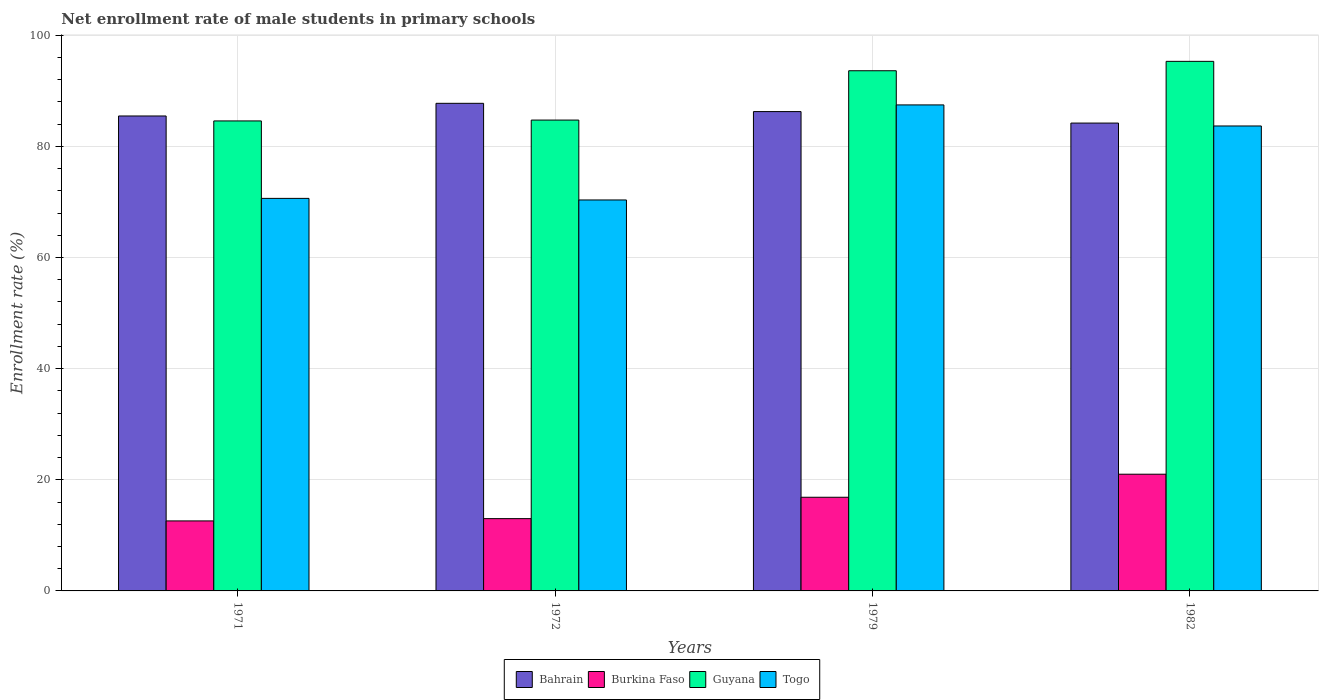How many groups of bars are there?
Give a very brief answer. 4. Are the number of bars on each tick of the X-axis equal?
Make the answer very short. Yes. How many bars are there on the 3rd tick from the right?
Offer a terse response. 4. What is the label of the 3rd group of bars from the left?
Offer a very short reply. 1979. In how many cases, is the number of bars for a given year not equal to the number of legend labels?
Your response must be concise. 0. What is the net enrollment rate of male students in primary schools in Togo in 1979?
Offer a very short reply. 87.47. Across all years, what is the maximum net enrollment rate of male students in primary schools in Burkina Faso?
Make the answer very short. 21.01. Across all years, what is the minimum net enrollment rate of male students in primary schools in Guyana?
Give a very brief answer. 84.59. In which year was the net enrollment rate of male students in primary schools in Burkina Faso minimum?
Your answer should be compact. 1971. What is the total net enrollment rate of male students in primary schools in Burkina Faso in the graph?
Your answer should be compact. 63.47. What is the difference between the net enrollment rate of male students in primary schools in Bahrain in 1979 and that in 1982?
Ensure brevity in your answer.  2.07. What is the difference between the net enrollment rate of male students in primary schools in Togo in 1971 and the net enrollment rate of male students in primary schools in Guyana in 1979?
Your answer should be very brief. -22.97. What is the average net enrollment rate of male students in primary schools in Bahrain per year?
Provide a short and direct response. 85.92. In the year 1972, what is the difference between the net enrollment rate of male students in primary schools in Guyana and net enrollment rate of male students in primary schools in Togo?
Your response must be concise. 14.38. In how many years, is the net enrollment rate of male students in primary schools in Togo greater than 96 %?
Give a very brief answer. 0. What is the ratio of the net enrollment rate of male students in primary schools in Burkina Faso in 1971 to that in 1982?
Provide a short and direct response. 0.6. Is the net enrollment rate of male students in primary schools in Burkina Faso in 1971 less than that in 1982?
Give a very brief answer. Yes. Is the difference between the net enrollment rate of male students in primary schools in Guyana in 1979 and 1982 greater than the difference between the net enrollment rate of male students in primary schools in Togo in 1979 and 1982?
Offer a terse response. No. What is the difference between the highest and the second highest net enrollment rate of male students in primary schools in Bahrain?
Provide a short and direct response. 1.49. What is the difference between the highest and the lowest net enrollment rate of male students in primary schools in Bahrain?
Provide a succinct answer. 3.55. Is it the case that in every year, the sum of the net enrollment rate of male students in primary schools in Togo and net enrollment rate of male students in primary schools in Guyana is greater than the sum of net enrollment rate of male students in primary schools in Burkina Faso and net enrollment rate of male students in primary schools in Bahrain?
Ensure brevity in your answer.  No. What does the 3rd bar from the left in 1971 represents?
Provide a short and direct response. Guyana. What does the 3rd bar from the right in 1972 represents?
Keep it short and to the point. Burkina Faso. Are all the bars in the graph horizontal?
Give a very brief answer. No. How many years are there in the graph?
Ensure brevity in your answer.  4. What is the difference between two consecutive major ticks on the Y-axis?
Keep it short and to the point. 20. Does the graph contain any zero values?
Provide a short and direct response. No. How many legend labels are there?
Ensure brevity in your answer.  4. How are the legend labels stacked?
Provide a short and direct response. Horizontal. What is the title of the graph?
Offer a terse response. Net enrollment rate of male students in primary schools. What is the label or title of the X-axis?
Your answer should be very brief. Years. What is the label or title of the Y-axis?
Give a very brief answer. Enrollment rate (%). What is the Enrollment rate (%) of Bahrain in 1971?
Offer a terse response. 85.48. What is the Enrollment rate (%) in Burkina Faso in 1971?
Make the answer very short. 12.6. What is the Enrollment rate (%) in Guyana in 1971?
Ensure brevity in your answer.  84.59. What is the Enrollment rate (%) of Togo in 1971?
Give a very brief answer. 70.65. What is the Enrollment rate (%) in Bahrain in 1972?
Your response must be concise. 87.75. What is the Enrollment rate (%) of Burkina Faso in 1972?
Your response must be concise. 13.01. What is the Enrollment rate (%) in Guyana in 1972?
Your answer should be very brief. 84.74. What is the Enrollment rate (%) of Togo in 1972?
Make the answer very short. 70.36. What is the Enrollment rate (%) in Bahrain in 1979?
Give a very brief answer. 86.27. What is the Enrollment rate (%) of Burkina Faso in 1979?
Keep it short and to the point. 16.86. What is the Enrollment rate (%) of Guyana in 1979?
Your response must be concise. 93.62. What is the Enrollment rate (%) of Togo in 1979?
Your answer should be compact. 87.47. What is the Enrollment rate (%) in Bahrain in 1982?
Offer a terse response. 84.2. What is the Enrollment rate (%) in Burkina Faso in 1982?
Your answer should be very brief. 21.01. What is the Enrollment rate (%) of Guyana in 1982?
Provide a succinct answer. 95.31. What is the Enrollment rate (%) of Togo in 1982?
Make the answer very short. 83.68. Across all years, what is the maximum Enrollment rate (%) in Bahrain?
Ensure brevity in your answer.  87.75. Across all years, what is the maximum Enrollment rate (%) in Burkina Faso?
Make the answer very short. 21.01. Across all years, what is the maximum Enrollment rate (%) of Guyana?
Ensure brevity in your answer.  95.31. Across all years, what is the maximum Enrollment rate (%) of Togo?
Make the answer very short. 87.47. Across all years, what is the minimum Enrollment rate (%) in Bahrain?
Make the answer very short. 84.2. Across all years, what is the minimum Enrollment rate (%) in Burkina Faso?
Your answer should be very brief. 12.6. Across all years, what is the minimum Enrollment rate (%) of Guyana?
Provide a short and direct response. 84.59. Across all years, what is the minimum Enrollment rate (%) of Togo?
Your answer should be very brief. 70.36. What is the total Enrollment rate (%) of Bahrain in the graph?
Offer a very short reply. 343.7. What is the total Enrollment rate (%) in Burkina Faso in the graph?
Provide a short and direct response. 63.47. What is the total Enrollment rate (%) in Guyana in the graph?
Ensure brevity in your answer.  358.25. What is the total Enrollment rate (%) in Togo in the graph?
Your response must be concise. 312.16. What is the difference between the Enrollment rate (%) of Bahrain in 1971 and that in 1972?
Your answer should be very brief. -2.28. What is the difference between the Enrollment rate (%) in Burkina Faso in 1971 and that in 1972?
Provide a succinct answer. -0.41. What is the difference between the Enrollment rate (%) of Guyana in 1971 and that in 1972?
Your response must be concise. -0.15. What is the difference between the Enrollment rate (%) of Togo in 1971 and that in 1972?
Ensure brevity in your answer.  0.28. What is the difference between the Enrollment rate (%) in Bahrain in 1971 and that in 1979?
Provide a succinct answer. -0.79. What is the difference between the Enrollment rate (%) of Burkina Faso in 1971 and that in 1979?
Your answer should be compact. -4.26. What is the difference between the Enrollment rate (%) of Guyana in 1971 and that in 1979?
Ensure brevity in your answer.  -9.03. What is the difference between the Enrollment rate (%) in Togo in 1971 and that in 1979?
Your answer should be compact. -16.82. What is the difference between the Enrollment rate (%) in Bahrain in 1971 and that in 1982?
Make the answer very short. 1.28. What is the difference between the Enrollment rate (%) of Burkina Faso in 1971 and that in 1982?
Your answer should be very brief. -8.4. What is the difference between the Enrollment rate (%) in Guyana in 1971 and that in 1982?
Offer a very short reply. -10.72. What is the difference between the Enrollment rate (%) of Togo in 1971 and that in 1982?
Your response must be concise. -13.03. What is the difference between the Enrollment rate (%) in Bahrain in 1972 and that in 1979?
Your answer should be very brief. 1.49. What is the difference between the Enrollment rate (%) of Burkina Faso in 1972 and that in 1979?
Make the answer very short. -3.84. What is the difference between the Enrollment rate (%) in Guyana in 1972 and that in 1979?
Keep it short and to the point. -8.88. What is the difference between the Enrollment rate (%) of Togo in 1972 and that in 1979?
Make the answer very short. -17.11. What is the difference between the Enrollment rate (%) in Bahrain in 1972 and that in 1982?
Provide a short and direct response. 3.55. What is the difference between the Enrollment rate (%) of Burkina Faso in 1972 and that in 1982?
Offer a terse response. -7.99. What is the difference between the Enrollment rate (%) in Guyana in 1972 and that in 1982?
Offer a very short reply. -10.57. What is the difference between the Enrollment rate (%) in Togo in 1972 and that in 1982?
Provide a short and direct response. -13.32. What is the difference between the Enrollment rate (%) of Bahrain in 1979 and that in 1982?
Offer a very short reply. 2.07. What is the difference between the Enrollment rate (%) in Burkina Faso in 1979 and that in 1982?
Your response must be concise. -4.15. What is the difference between the Enrollment rate (%) in Guyana in 1979 and that in 1982?
Provide a succinct answer. -1.69. What is the difference between the Enrollment rate (%) of Togo in 1979 and that in 1982?
Provide a short and direct response. 3.79. What is the difference between the Enrollment rate (%) in Bahrain in 1971 and the Enrollment rate (%) in Burkina Faso in 1972?
Ensure brevity in your answer.  72.47. What is the difference between the Enrollment rate (%) in Bahrain in 1971 and the Enrollment rate (%) in Guyana in 1972?
Provide a short and direct response. 0.74. What is the difference between the Enrollment rate (%) of Bahrain in 1971 and the Enrollment rate (%) of Togo in 1972?
Your answer should be compact. 15.11. What is the difference between the Enrollment rate (%) of Burkina Faso in 1971 and the Enrollment rate (%) of Guyana in 1972?
Make the answer very short. -72.14. What is the difference between the Enrollment rate (%) of Burkina Faso in 1971 and the Enrollment rate (%) of Togo in 1972?
Your answer should be very brief. -57.76. What is the difference between the Enrollment rate (%) of Guyana in 1971 and the Enrollment rate (%) of Togo in 1972?
Your answer should be very brief. 14.22. What is the difference between the Enrollment rate (%) in Bahrain in 1971 and the Enrollment rate (%) in Burkina Faso in 1979?
Ensure brevity in your answer.  68.62. What is the difference between the Enrollment rate (%) of Bahrain in 1971 and the Enrollment rate (%) of Guyana in 1979?
Offer a very short reply. -8.14. What is the difference between the Enrollment rate (%) of Bahrain in 1971 and the Enrollment rate (%) of Togo in 1979?
Provide a short and direct response. -1.99. What is the difference between the Enrollment rate (%) in Burkina Faso in 1971 and the Enrollment rate (%) in Guyana in 1979?
Make the answer very short. -81.02. What is the difference between the Enrollment rate (%) of Burkina Faso in 1971 and the Enrollment rate (%) of Togo in 1979?
Offer a very short reply. -74.87. What is the difference between the Enrollment rate (%) in Guyana in 1971 and the Enrollment rate (%) in Togo in 1979?
Ensure brevity in your answer.  -2.88. What is the difference between the Enrollment rate (%) in Bahrain in 1971 and the Enrollment rate (%) in Burkina Faso in 1982?
Offer a terse response. 64.47. What is the difference between the Enrollment rate (%) of Bahrain in 1971 and the Enrollment rate (%) of Guyana in 1982?
Make the answer very short. -9.83. What is the difference between the Enrollment rate (%) of Bahrain in 1971 and the Enrollment rate (%) of Togo in 1982?
Your answer should be compact. 1.8. What is the difference between the Enrollment rate (%) of Burkina Faso in 1971 and the Enrollment rate (%) of Guyana in 1982?
Make the answer very short. -82.71. What is the difference between the Enrollment rate (%) of Burkina Faso in 1971 and the Enrollment rate (%) of Togo in 1982?
Offer a very short reply. -71.08. What is the difference between the Enrollment rate (%) in Guyana in 1971 and the Enrollment rate (%) in Togo in 1982?
Provide a succinct answer. 0.91. What is the difference between the Enrollment rate (%) in Bahrain in 1972 and the Enrollment rate (%) in Burkina Faso in 1979?
Ensure brevity in your answer.  70.9. What is the difference between the Enrollment rate (%) of Bahrain in 1972 and the Enrollment rate (%) of Guyana in 1979?
Give a very brief answer. -5.86. What is the difference between the Enrollment rate (%) of Bahrain in 1972 and the Enrollment rate (%) of Togo in 1979?
Give a very brief answer. 0.29. What is the difference between the Enrollment rate (%) of Burkina Faso in 1972 and the Enrollment rate (%) of Guyana in 1979?
Your response must be concise. -80.61. What is the difference between the Enrollment rate (%) of Burkina Faso in 1972 and the Enrollment rate (%) of Togo in 1979?
Provide a succinct answer. -74.46. What is the difference between the Enrollment rate (%) of Guyana in 1972 and the Enrollment rate (%) of Togo in 1979?
Provide a succinct answer. -2.73. What is the difference between the Enrollment rate (%) in Bahrain in 1972 and the Enrollment rate (%) in Burkina Faso in 1982?
Keep it short and to the point. 66.75. What is the difference between the Enrollment rate (%) of Bahrain in 1972 and the Enrollment rate (%) of Guyana in 1982?
Your answer should be very brief. -7.55. What is the difference between the Enrollment rate (%) in Bahrain in 1972 and the Enrollment rate (%) in Togo in 1982?
Keep it short and to the point. 4.08. What is the difference between the Enrollment rate (%) in Burkina Faso in 1972 and the Enrollment rate (%) in Guyana in 1982?
Your response must be concise. -82.3. What is the difference between the Enrollment rate (%) in Burkina Faso in 1972 and the Enrollment rate (%) in Togo in 1982?
Offer a very short reply. -70.67. What is the difference between the Enrollment rate (%) of Guyana in 1972 and the Enrollment rate (%) of Togo in 1982?
Give a very brief answer. 1.06. What is the difference between the Enrollment rate (%) of Bahrain in 1979 and the Enrollment rate (%) of Burkina Faso in 1982?
Offer a very short reply. 65.26. What is the difference between the Enrollment rate (%) in Bahrain in 1979 and the Enrollment rate (%) in Guyana in 1982?
Offer a very short reply. -9.04. What is the difference between the Enrollment rate (%) of Bahrain in 1979 and the Enrollment rate (%) of Togo in 1982?
Keep it short and to the point. 2.59. What is the difference between the Enrollment rate (%) of Burkina Faso in 1979 and the Enrollment rate (%) of Guyana in 1982?
Offer a terse response. -78.45. What is the difference between the Enrollment rate (%) in Burkina Faso in 1979 and the Enrollment rate (%) in Togo in 1982?
Offer a terse response. -66.82. What is the difference between the Enrollment rate (%) in Guyana in 1979 and the Enrollment rate (%) in Togo in 1982?
Provide a succinct answer. 9.94. What is the average Enrollment rate (%) of Bahrain per year?
Your answer should be compact. 85.92. What is the average Enrollment rate (%) in Burkina Faso per year?
Your response must be concise. 15.87. What is the average Enrollment rate (%) of Guyana per year?
Your response must be concise. 89.56. What is the average Enrollment rate (%) in Togo per year?
Your answer should be very brief. 78.04. In the year 1971, what is the difference between the Enrollment rate (%) of Bahrain and Enrollment rate (%) of Burkina Faso?
Ensure brevity in your answer.  72.88. In the year 1971, what is the difference between the Enrollment rate (%) in Bahrain and Enrollment rate (%) in Guyana?
Provide a short and direct response. 0.89. In the year 1971, what is the difference between the Enrollment rate (%) of Bahrain and Enrollment rate (%) of Togo?
Make the answer very short. 14.83. In the year 1971, what is the difference between the Enrollment rate (%) of Burkina Faso and Enrollment rate (%) of Guyana?
Offer a terse response. -71.99. In the year 1971, what is the difference between the Enrollment rate (%) of Burkina Faso and Enrollment rate (%) of Togo?
Offer a terse response. -58.05. In the year 1971, what is the difference between the Enrollment rate (%) of Guyana and Enrollment rate (%) of Togo?
Ensure brevity in your answer.  13.94. In the year 1972, what is the difference between the Enrollment rate (%) of Bahrain and Enrollment rate (%) of Burkina Faso?
Your answer should be compact. 74.74. In the year 1972, what is the difference between the Enrollment rate (%) in Bahrain and Enrollment rate (%) in Guyana?
Your answer should be compact. 3.01. In the year 1972, what is the difference between the Enrollment rate (%) of Bahrain and Enrollment rate (%) of Togo?
Ensure brevity in your answer.  17.39. In the year 1972, what is the difference between the Enrollment rate (%) of Burkina Faso and Enrollment rate (%) of Guyana?
Your answer should be compact. -71.73. In the year 1972, what is the difference between the Enrollment rate (%) of Burkina Faso and Enrollment rate (%) of Togo?
Provide a short and direct response. -57.35. In the year 1972, what is the difference between the Enrollment rate (%) in Guyana and Enrollment rate (%) in Togo?
Your answer should be compact. 14.38. In the year 1979, what is the difference between the Enrollment rate (%) in Bahrain and Enrollment rate (%) in Burkina Faso?
Keep it short and to the point. 69.41. In the year 1979, what is the difference between the Enrollment rate (%) in Bahrain and Enrollment rate (%) in Guyana?
Provide a succinct answer. -7.35. In the year 1979, what is the difference between the Enrollment rate (%) of Bahrain and Enrollment rate (%) of Togo?
Your response must be concise. -1.2. In the year 1979, what is the difference between the Enrollment rate (%) of Burkina Faso and Enrollment rate (%) of Guyana?
Your answer should be very brief. -76.76. In the year 1979, what is the difference between the Enrollment rate (%) of Burkina Faso and Enrollment rate (%) of Togo?
Ensure brevity in your answer.  -70.61. In the year 1979, what is the difference between the Enrollment rate (%) of Guyana and Enrollment rate (%) of Togo?
Your response must be concise. 6.15. In the year 1982, what is the difference between the Enrollment rate (%) in Bahrain and Enrollment rate (%) in Burkina Faso?
Offer a very short reply. 63.19. In the year 1982, what is the difference between the Enrollment rate (%) in Bahrain and Enrollment rate (%) in Guyana?
Your response must be concise. -11.11. In the year 1982, what is the difference between the Enrollment rate (%) in Bahrain and Enrollment rate (%) in Togo?
Give a very brief answer. 0.52. In the year 1982, what is the difference between the Enrollment rate (%) in Burkina Faso and Enrollment rate (%) in Guyana?
Your answer should be compact. -74.3. In the year 1982, what is the difference between the Enrollment rate (%) of Burkina Faso and Enrollment rate (%) of Togo?
Offer a terse response. -62.67. In the year 1982, what is the difference between the Enrollment rate (%) in Guyana and Enrollment rate (%) in Togo?
Offer a terse response. 11.63. What is the ratio of the Enrollment rate (%) of Burkina Faso in 1971 to that in 1972?
Your response must be concise. 0.97. What is the ratio of the Enrollment rate (%) in Burkina Faso in 1971 to that in 1979?
Ensure brevity in your answer.  0.75. What is the ratio of the Enrollment rate (%) of Guyana in 1971 to that in 1979?
Provide a short and direct response. 0.9. What is the ratio of the Enrollment rate (%) in Togo in 1971 to that in 1979?
Your answer should be compact. 0.81. What is the ratio of the Enrollment rate (%) in Bahrain in 1971 to that in 1982?
Give a very brief answer. 1.02. What is the ratio of the Enrollment rate (%) of Burkina Faso in 1971 to that in 1982?
Offer a very short reply. 0.6. What is the ratio of the Enrollment rate (%) in Guyana in 1971 to that in 1982?
Offer a terse response. 0.89. What is the ratio of the Enrollment rate (%) of Togo in 1971 to that in 1982?
Give a very brief answer. 0.84. What is the ratio of the Enrollment rate (%) of Bahrain in 1972 to that in 1979?
Offer a very short reply. 1.02. What is the ratio of the Enrollment rate (%) in Burkina Faso in 1972 to that in 1979?
Make the answer very short. 0.77. What is the ratio of the Enrollment rate (%) in Guyana in 1972 to that in 1979?
Your answer should be compact. 0.91. What is the ratio of the Enrollment rate (%) of Togo in 1972 to that in 1979?
Provide a succinct answer. 0.8. What is the ratio of the Enrollment rate (%) in Bahrain in 1972 to that in 1982?
Provide a short and direct response. 1.04. What is the ratio of the Enrollment rate (%) of Burkina Faso in 1972 to that in 1982?
Keep it short and to the point. 0.62. What is the ratio of the Enrollment rate (%) of Guyana in 1972 to that in 1982?
Your answer should be very brief. 0.89. What is the ratio of the Enrollment rate (%) in Togo in 1972 to that in 1982?
Ensure brevity in your answer.  0.84. What is the ratio of the Enrollment rate (%) of Bahrain in 1979 to that in 1982?
Make the answer very short. 1.02. What is the ratio of the Enrollment rate (%) in Burkina Faso in 1979 to that in 1982?
Your answer should be very brief. 0.8. What is the ratio of the Enrollment rate (%) of Guyana in 1979 to that in 1982?
Keep it short and to the point. 0.98. What is the ratio of the Enrollment rate (%) of Togo in 1979 to that in 1982?
Provide a succinct answer. 1.05. What is the difference between the highest and the second highest Enrollment rate (%) in Bahrain?
Give a very brief answer. 1.49. What is the difference between the highest and the second highest Enrollment rate (%) of Burkina Faso?
Provide a succinct answer. 4.15. What is the difference between the highest and the second highest Enrollment rate (%) of Guyana?
Ensure brevity in your answer.  1.69. What is the difference between the highest and the second highest Enrollment rate (%) in Togo?
Keep it short and to the point. 3.79. What is the difference between the highest and the lowest Enrollment rate (%) of Bahrain?
Make the answer very short. 3.55. What is the difference between the highest and the lowest Enrollment rate (%) of Burkina Faso?
Your answer should be compact. 8.4. What is the difference between the highest and the lowest Enrollment rate (%) of Guyana?
Your response must be concise. 10.72. What is the difference between the highest and the lowest Enrollment rate (%) of Togo?
Offer a terse response. 17.11. 